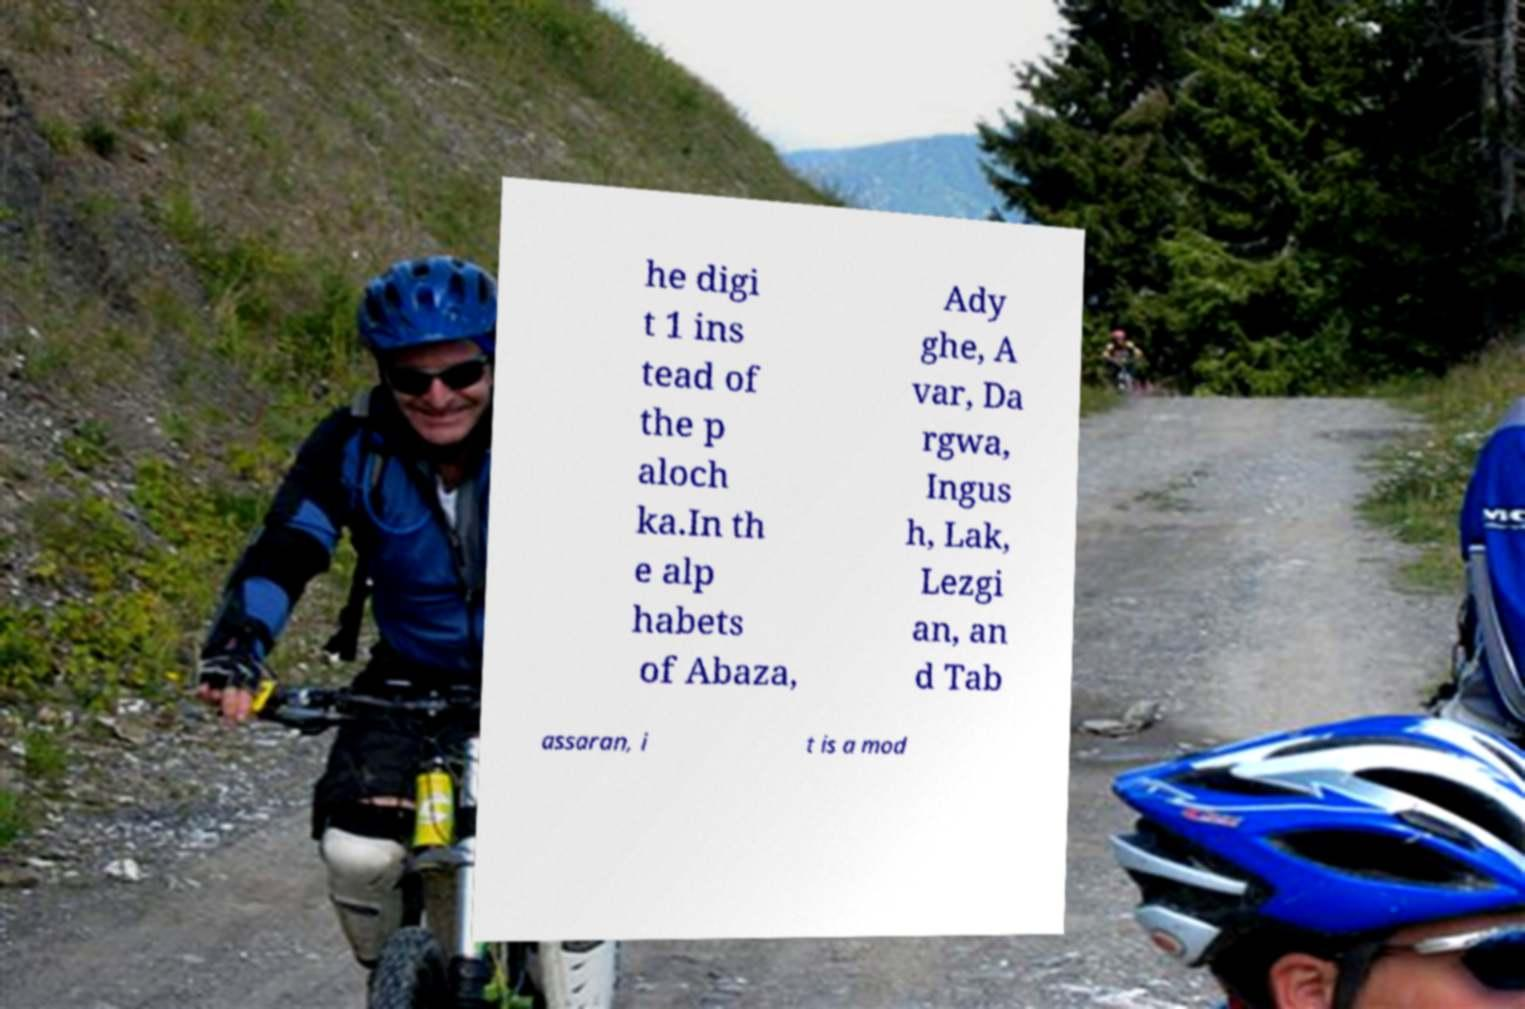Can you read and provide the text displayed in the image?This photo seems to have some interesting text. Can you extract and type it out for me? he digi t 1 ins tead of the p aloch ka.In th e alp habets of Abaza, Ady ghe, A var, Da rgwa, Ingus h, Lak, Lezgi an, an d Tab assaran, i t is a mod 